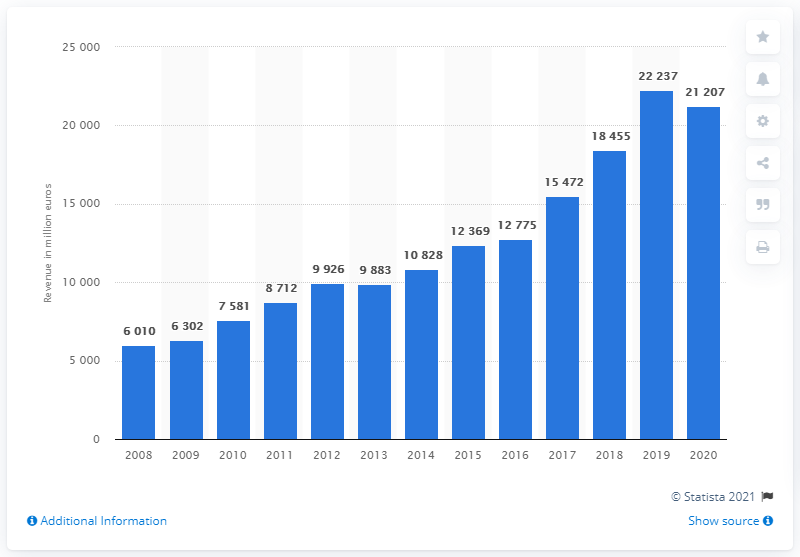Highlight a few significant elements in this photo. The revenue of the LVMH Group's fashion and leather goods segment in 2020 was 21,207. 